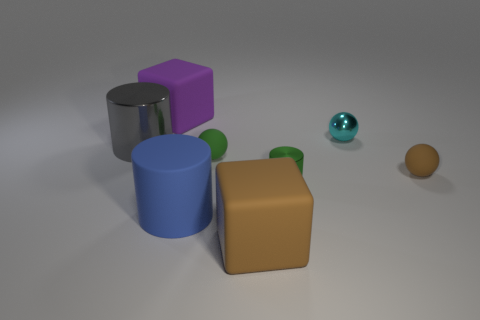Subtract all matte spheres. How many spheres are left? 1 Subtract all spheres. How many objects are left? 5 Subtract 1 cylinders. How many cylinders are left? 2 Add 2 rubber blocks. How many objects exist? 10 Subtract all purple cubes. How many cubes are left? 1 Subtract 0 purple spheres. How many objects are left? 8 Subtract all yellow spheres. Subtract all red blocks. How many spheres are left? 3 Subtract all blue balls. How many purple cubes are left? 1 Subtract all blocks. Subtract all small green rubber spheres. How many objects are left? 5 Add 6 big brown things. How many big brown things are left? 7 